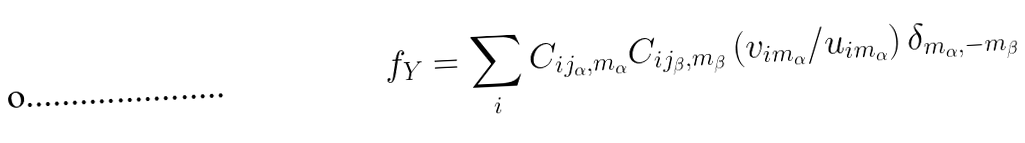<formula> <loc_0><loc_0><loc_500><loc_500>f _ { Y } = \sum _ { i } C _ { i j _ { \alpha } , m _ { \alpha } } C _ { i j _ { \beta } , m _ { \beta } } \left ( v _ { i m _ { \alpha } } / u _ { i m _ { \alpha } } \right ) \delta _ { m _ { \alpha } , - m _ { \beta } }</formula> 